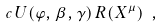<formula> <loc_0><loc_0><loc_500><loc_500>c \, U ( \varphi , \beta , \gamma ) \, R ( X ^ { \mu } ) \ ,</formula> 